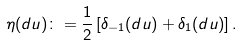Convert formula to latex. <formula><loc_0><loc_0><loc_500><loc_500>\eta ( d u ) \colon = \frac { 1 } { 2 } \left [ \delta _ { - 1 } ( d u ) + \delta _ { 1 } ( d u ) \right ] .</formula> 